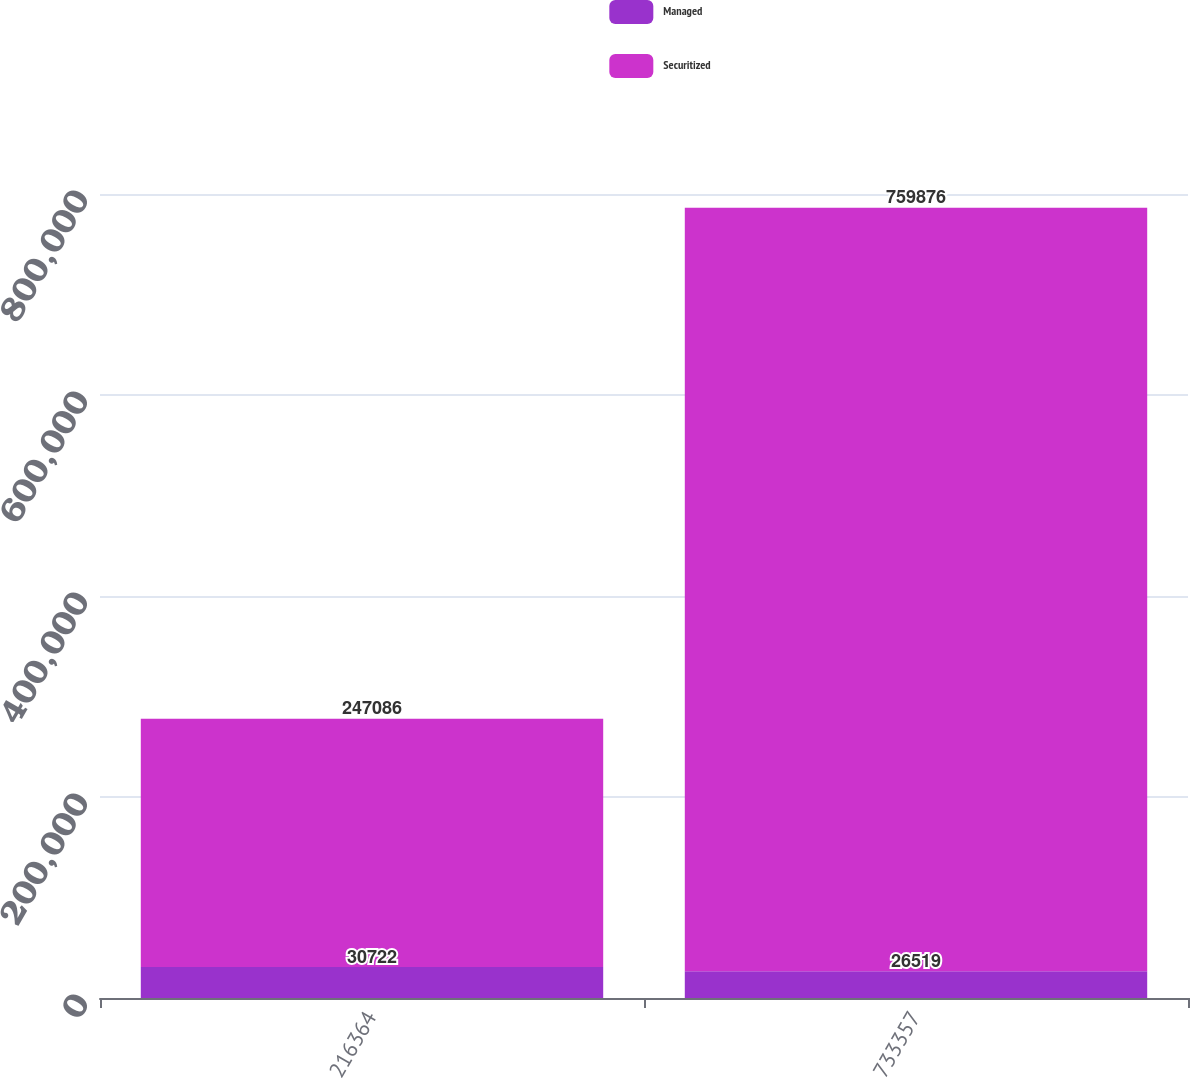Convert chart. <chart><loc_0><loc_0><loc_500><loc_500><stacked_bar_chart><ecel><fcel>216364<fcel>733357<nl><fcel>Managed<fcel>30722<fcel>26519<nl><fcel>Securitized<fcel>247086<fcel>759876<nl></chart> 